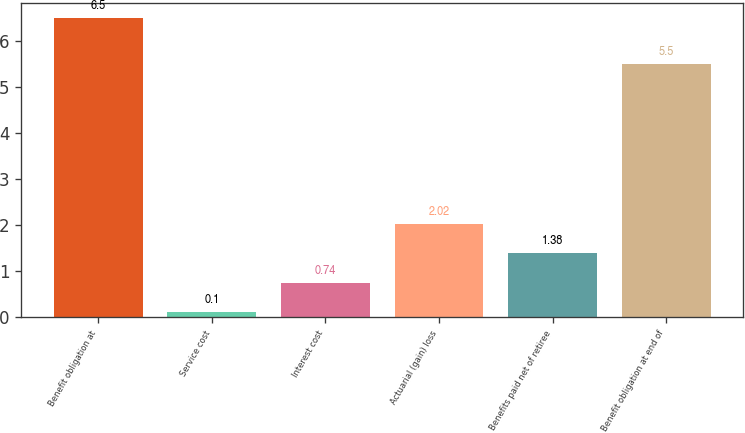Convert chart to OTSL. <chart><loc_0><loc_0><loc_500><loc_500><bar_chart><fcel>Benefit obligation at<fcel>Service cost<fcel>Interest cost<fcel>Actuarial (gain) loss<fcel>Benefits paid net of retiree<fcel>Benefit obligation at end of<nl><fcel>6.5<fcel>0.1<fcel>0.74<fcel>2.02<fcel>1.38<fcel>5.5<nl></chart> 